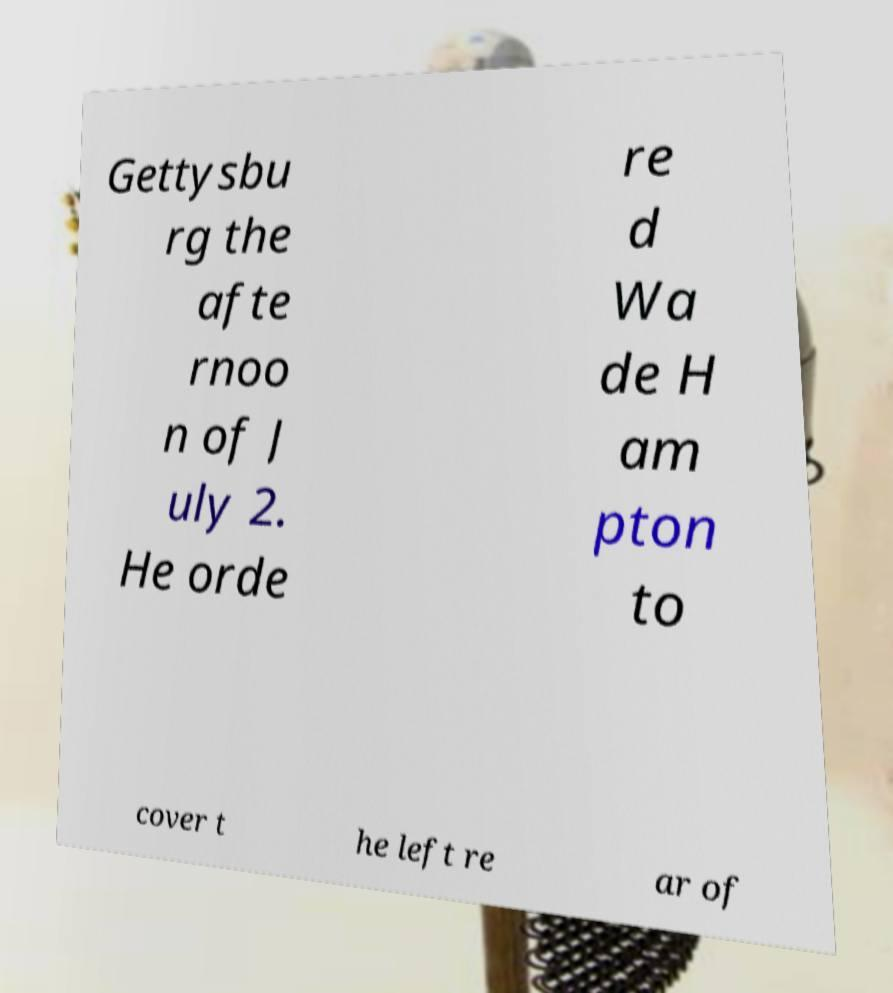I need the written content from this picture converted into text. Can you do that? Gettysbu rg the afte rnoo n of J uly 2. He orde re d Wa de H am pton to cover t he left re ar of 